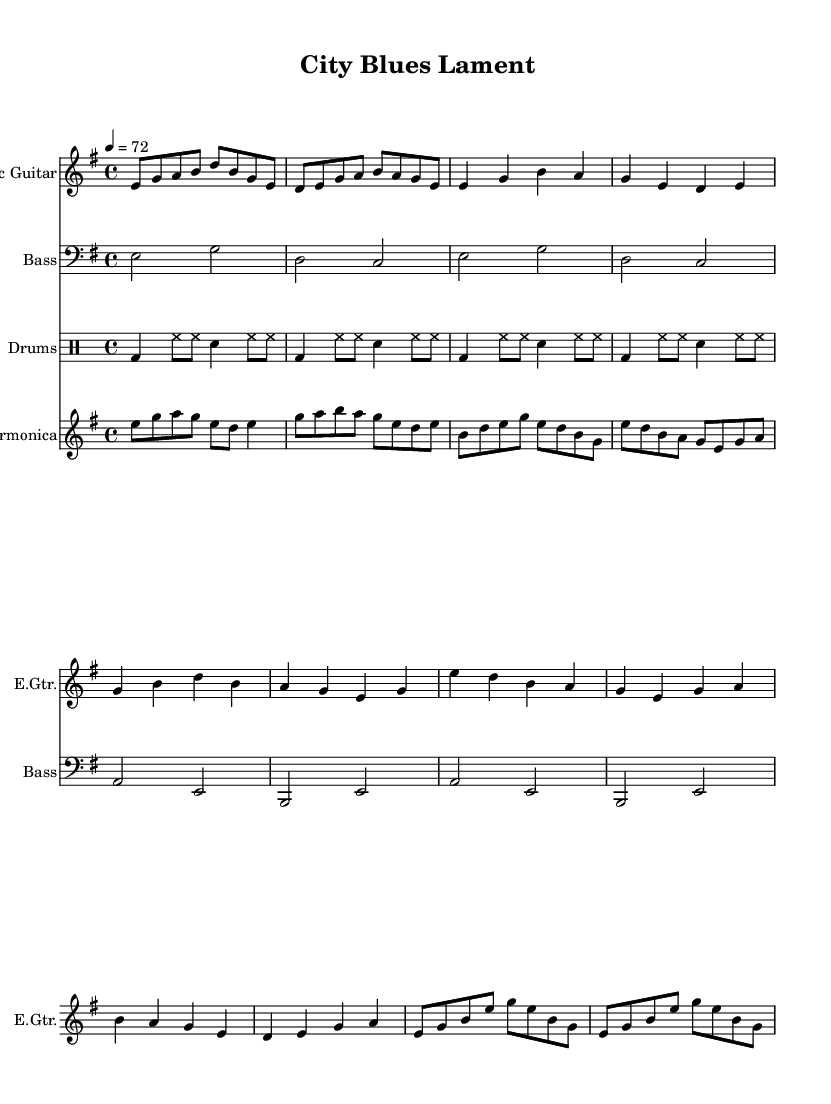What is the key signature of this music? The key signature is E minor, which has one sharp (F#). This is identifiable by locating the key signature at the beginning of the staff where the sharps or flats are listed.
Answer: E minor What is the time signature of this music? The time signature is 4/4, which means there are four beats per measure, and the quarter note receives one beat. This can be confirmed by examining the top portion of the sheet music where the time signature is displayed.
Answer: 4/4 What is the tempo marking for this piece? The tempo marking is 72 beats per minute, indicating the speed of the music. This is visible in the sheet music where tempo is provided, typically noted in beats per minute.
Answer: 72 How many measures are in the verse section? The verse section contains four measures. This can be determined by counting the individual measures within the verse segment of the sheet music.
Answer: 4 What rhythmic pattern is used in the drums? The rhythmic pattern in the drums consists of basic beats alternating with hi-hat and snare hits. This pattern can be identified by analyzing the drum notation in the drum staff, where the bass drum (bd), hi-hat (hh), and snare (sn) are clearly mapped out across the measures.
Answer: Basic rhythm pattern Which instrument plays the harmonica solo? The harmonica plays the solo passages. This can be inferred by observing the staff labeled "Harmonica" in the sheet music, where specific melodic lines are assigned to that instrument.
Answer: Harmonica 